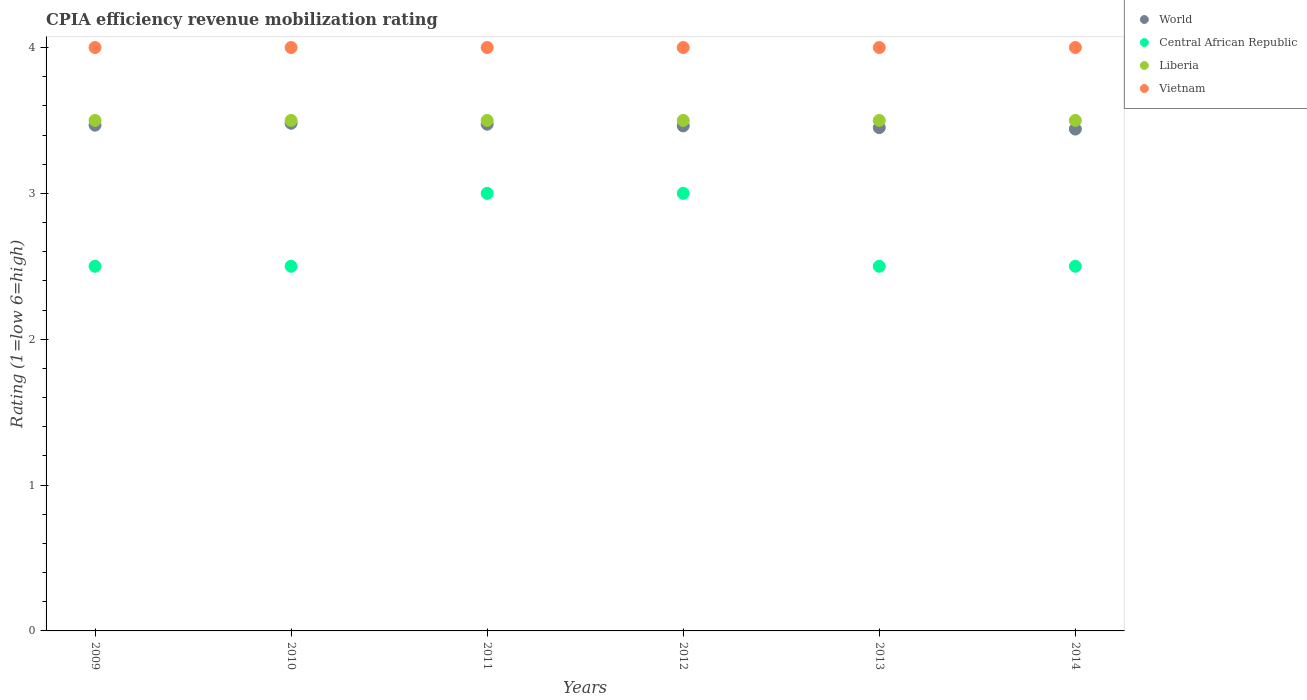How many different coloured dotlines are there?
Ensure brevity in your answer.  4. Across all years, what is the maximum CPIA rating in Vietnam?
Give a very brief answer. 4. Across all years, what is the minimum CPIA rating in Liberia?
Keep it short and to the point. 3.5. What is the difference between the CPIA rating in Vietnam in 2011 and the CPIA rating in World in 2014?
Keep it short and to the point. 0.56. What is the average CPIA rating in World per year?
Offer a terse response. 3.46. In the year 2012, what is the difference between the CPIA rating in Liberia and CPIA rating in World?
Provide a succinct answer. 0.04. In how many years, is the CPIA rating in Liberia greater than 3.4?
Make the answer very short. 6. What is the ratio of the CPIA rating in Liberia in 2009 to that in 2014?
Ensure brevity in your answer.  1. Is the difference between the CPIA rating in Liberia in 2009 and 2013 greater than the difference between the CPIA rating in World in 2009 and 2013?
Your response must be concise. No. What is the difference between the highest and the second highest CPIA rating in Liberia?
Ensure brevity in your answer.  0. Is it the case that in every year, the sum of the CPIA rating in Liberia and CPIA rating in World  is greater than the CPIA rating in Central African Republic?
Provide a short and direct response. Yes. Does the CPIA rating in World monotonically increase over the years?
Offer a terse response. No. How many dotlines are there?
Your answer should be very brief. 4. Are the values on the major ticks of Y-axis written in scientific E-notation?
Make the answer very short. No. Where does the legend appear in the graph?
Keep it short and to the point. Top right. What is the title of the graph?
Offer a terse response. CPIA efficiency revenue mobilization rating. Does "Hungary" appear as one of the legend labels in the graph?
Provide a short and direct response. No. What is the label or title of the X-axis?
Provide a short and direct response. Years. What is the Rating (1=low 6=high) of World in 2009?
Offer a very short reply. 3.47. What is the Rating (1=low 6=high) in Vietnam in 2009?
Offer a very short reply. 4. What is the Rating (1=low 6=high) of World in 2010?
Provide a short and direct response. 3.48. What is the Rating (1=low 6=high) in Liberia in 2010?
Give a very brief answer. 3.5. What is the Rating (1=low 6=high) of World in 2011?
Your answer should be compact. 3.47. What is the Rating (1=low 6=high) of Central African Republic in 2011?
Ensure brevity in your answer.  3. What is the Rating (1=low 6=high) of Vietnam in 2011?
Your answer should be compact. 4. What is the Rating (1=low 6=high) in World in 2012?
Your response must be concise. 3.46. What is the Rating (1=low 6=high) in Liberia in 2012?
Ensure brevity in your answer.  3.5. What is the Rating (1=low 6=high) in Vietnam in 2012?
Your answer should be compact. 4. What is the Rating (1=low 6=high) of World in 2013?
Your response must be concise. 3.45. What is the Rating (1=low 6=high) of Central African Republic in 2013?
Provide a short and direct response. 2.5. What is the Rating (1=low 6=high) in World in 2014?
Provide a succinct answer. 3.44. Across all years, what is the maximum Rating (1=low 6=high) in World?
Your answer should be very brief. 3.48. Across all years, what is the maximum Rating (1=low 6=high) of Central African Republic?
Provide a succinct answer. 3. Across all years, what is the minimum Rating (1=low 6=high) in World?
Offer a very short reply. 3.44. What is the total Rating (1=low 6=high) in World in the graph?
Keep it short and to the point. 20.78. What is the total Rating (1=low 6=high) of Central African Republic in the graph?
Ensure brevity in your answer.  16. What is the total Rating (1=low 6=high) of Liberia in the graph?
Give a very brief answer. 21. What is the total Rating (1=low 6=high) of Vietnam in the graph?
Your response must be concise. 24. What is the difference between the Rating (1=low 6=high) of World in 2009 and that in 2010?
Give a very brief answer. -0.01. What is the difference between the Rating (1=low 6=high) of Vietnam in 2009 and that in 2010?
Offer a terse response. 0. What is the difference between the Rating (1=low 6=high) of World in 2009 and that in 2011?
Give a very brief answer. -0.01. What is the difference between the Rating (1=low 6=high) of Liberia in 2009 and that in 2011?
Offer a terse response. 0. What is the difference between the Rating (1=low 6=high) in World in 2009 and that in 2012?
Offer a terse response. 0.01. What is the difference between the Rating (1=low 6=high) of World in 2009 and that in 2013?
Give a very brief answer. 0.02. What is the difference between the Rating (1=low 6=high) of Central African Republic in 2009 and that in 2013?
Your response must be concise. 0. What is the difference between the Rating (1=low 6=high) of Liberia in 2009 and that in 2013?
Give a very brief answer. 0. What is the difference between the Rating (1=low 6=high) in Vietnam in 2009 and that in 2013?
Your answer should be very brief. 0. What is the difference between the Rating (1=low 6=high) of World in 2009 and that in 2014?
Give a very brief answer. 0.03. What is the difference between the Rating (1=low 6=high) in Vietnam in 2009 and that in 2014?
Provide a succinct answer. 0. What is the difference between the Rating (1=low 6=high) of World in 2010 and that in 2011?
Provide a short and direct response. 0.01. What is the difference between the Rating (1=low 6=high) in Liberia in 2010 and that in 2011?
Offer a terse response. 0. What is the difference between the Rating (1=low 6=high) in Vietnam in 2010 and that in 2011?
Your answer should be very brief. 0. What is the difference between the Rating (1=low 6=high) of World in 2010 and that in 2012?
Offer a very short reply. 0.02. What is the difference between the Rating (1=low 6=high) of Liberia in 2010 and that in 2012?
Your response must be concise. 0. What is the difference between the Rating (1=low 6=high) in Vietnam in 2010 and that in 2012?
Keep it short and to the point. 0. What is the difference between the Rating (1=low 6=high) of World in 2010 and that in 2013?
Your answer should be compact. 0.03. What is the difference between the Rating (1=low 6=high) in Central African Republic in 2010 and that in 2013?
Ensure brevity in your answer.  0. What is the difference between the Rating (1=low 6=high) in Liberia in 2010 and that in 2013?
Your answer should be very brief. 0. What is the difference between the Rating (1=low 6=high) of Vietnam in 2010 and that in 2013?
Keep it short and to the point. 0. What is the difference between the Rating (1=low 6=high) in World in 2010 and that in 2014?
Provide a succinct answer. 0.04. What is the difference between the Rating (1=low 6=high) of Vietnam in 2010 and that in 2014?
Provide a short and direct response. 0. What is the difference between the Rating (1=low 6=high) in World in 2011 and that in 2012?
Provide a succinct answer. 0.01. What is the difference between the Rating (1=low 6=high) of Central African Republic in 2011 and that in 2012?
Offer a very short reply. 0. What is the difference between the Rating (1=low 6=high) in Liberia in 2011 and that in 2012?
Your response must be concise. 0. What is the difference between the Rating (1=low 6=high) of Vietnam in 2011 and that in 2012?
Your response must be concise. 0. What is the difference between the Rating (1=low 6=high) in World in 2011 and that in 2013?
Your answer should be compact. 0.02. What is the difference between the Rating (1=low 6=high) in World in 2011 and that in 2014?
Provide a succinct answer. 0.03. What is the difference between the Rating (1=low 6=high) of Liberia in 2011 and that in 2014?
Your response must be concise. 0. What is the difference between the Rating (1=low 6=high) in World in 2012 and that in 2013?
Offer a terse response. 0.01. What is the difference between the Rating (1=low 6=high) of Central African Republic in 2012 and that in 2013?
Provide a succinct answer. 0.5. What is the difference between the Rating (1=low 6=high) in Vietnam in 2012 and that in 2013?
Ensure brevity in your answer.  0. What is the difference between the Rating (1=low 6=high) in World in 2012 and that in 2014?
Offer a terse response. 0.02. What is the difference between the Rating (1=low 6=high) of World in 2013 and that in 2014?
Offer a terse response. 0.01. What is the difference between the Rating (1=low 6=high) of Central African Republic in 2013 and that in 2014?
Make the answer very short. 0. What is the difference between the Rating (1=low 6=high) of Vietnam in 2013 and that in 2014?
Your answer should be very brief. 0. What is the difference between the Rating (1=low 6=high) in World in 2009 and the Rating (1=low 6=high) in Central African Republic in 2010?
Offer a terse response. 0.97. What is the difference between the Rating (1=low 6=high) in World in 2009 and the Rating (1=low 6=high) in Liberia in 2010?
Make the answer very short. -0.03. What is the difference between the Rating (1=low 6=high) in World in 2009 and the Rating (1=low 6=high) in Vietnam in 2010?
Your answer should be compact. -0.53. What is the difference between the Rating (1=low 6=high) in Liberia in 2009 and the Rating (1=low 6=high) in Vietnam in 2010?
Your response must be concise. -0.5. What is the difference between the Rating (1=low 6=high) in World in 2009 and the Rating (1=low 6=high) in Central African Republic in 2011?
Give a very brief answer. 0.47. What is the difference between the Rating (1=low 6=high) in World in 2009 and the Rating (1=low 6=high) in Liberia in 2011?
Keep it short and to the point. -0.03. What is the difference between the Rating (1=low 6=high) in World in 2009 and the Rating (1=low 6=high) in Vietnam in 2011?
Provide a short and direct response. -0.53. What is the difference between the Rating (1=low 6=high) in Central African Republic in 2009 and the Rating (1=low 6=high) in Vietnam in 2011?
Your answer should be compact. -1.5. What is the difference between the Rating (1=low 6=high) of World in 2009 and the Rating (1=low 6=high) of Central African Republic in 2012?
Provide a short and direct response. 0.47. What is the difference between the Rating (1=low 6=high) of World in 2009 and the Rating (1=low 6=high) of Liberia in 2012?
Offer a very short reply. -0.03. What is the difference between the Rating (1=low 6=high) of World in 2009 and the Rating (1=low 6=high) of Vietnam in 2012?
Make the answer very short. -0.53. What is the difference between the Rating (1=low 6=high) in Central African Republic in 2009 and the Rating (1=low 6=high) in Liberia in 2012?
Provide a succinct answer. -1. What is the difference between the Rating (1=low 6=high) in Liberia in 2009 and the Rating (1=low 6=high) in Vietnam in 2012?
Offer a terse response. -0.5. What is the difference between the Rating (1=low 6=high) in World in 2009 and the Rating (1=low 6=high) in Central African Republic in 2013?
Make the answer very short. 0.97. What is the difference between the Rating (1=low 6=high) in World in 2009 and the Rating (1=low 6=high) in Liberia in 2013?
Your answer should be very brief. -0.03. What is the difference between the Rating (1=low 6=high) in World in 2009 and the Rating (1=low 6=high) in Vietnam in 2013?
Keep it short and to the point. -0.53. What is the difference between the Rating (1=low 6=high) of Central African Republic in 2009 and the Rating (1=low 6=high) of Liberia in 2013?
Keep it short and to the point. -1. What is the difference between the Rating (1=low 6=high) in World in 2009 and the Rating (1=low 6=high) in Central African Republic in 2014?
Make the answer very short. 0.97. What is the difference between the Rating (1=low 6=high) in World in 2009 and the Rating (1=low 6=high) in Liberia in 2014?
Offer a terse response. -0.03. What is the difference between the Rating (1=low 6=high) in World in 2009 and the Rating (1=low 6=high) in Vietnam in 2014?
Provide a succinct answer. -0.53. What is the difference between the Rating (1=low 6=high) of Central African Republic in 2009 and the Rating (1=low 6=high) of Liberia in 2014?
Ensure brevity in your answer.  -1. What is the difference between the Rating (1=low 6=high) in Central African Republic in 2009 and the Rating (1=low 6=high) in Vietnam in 2014?
Give a very brief answer. -1.5. What is the difference between the Rating (1=low 6=high) in Liberia in 2009 and the Rating (1=low 6=high) in Vietnam in 2014?
Provide a short and direct response. -0.5. What is the difference between the Rating (1=low 6=high) in World in 2010 and the Rating (1=low 6=high) in Central African Republic in 2011?
Offer a very short reply. 0.48. What is the difference between the Rating (1=low 6=high) of World in 2010 and the Rating (1=low 6=high) of Liberia in 2011?
Keep it short and to the point. -0.02. What is the difference between the Rating (1=low 6=high) in World in 2010 and the Rating (1=low 6=high) in Vietnam in 2011?
Offer a very short reply. -0.52. What is the difference between the Rating (1=low 6=high) of Central African Republic in 2010 and the Rating (1=low 6=high) of Liberia in 2011?
Give a very brief answer. -1. What is the difference between the Rating (1=low 6=high) in Liberia in 2010 and the Rating (1=low 6=high) in Vietnam in 2011?
Make the answer very short. -0.5. What is the difference between the Rating (1=low 6=high) of World in 2010 and the Rating (1=low 6=high) of Central African Republic in 2012?
Your response must be concise. 0.48. What is the difference between the Rating (1=low 6=high) in World in 2010 and the Rating (1=low 6=high) in Liberia in 2012?
Ensure brevity in your answer.  -0.02. What is the difference between the Rating (1=low 6=high) in World in 2010 and the Rating (1=low 6=high) in Vietnam in 2012?
Make the answer very short. -0.52. What is the difference between the Rating (1=low 6=high) of Central African Republic in 2010 and the Rating (1=low 6=high) of Vietnam in 2012?
Make the answer very short. -1.5. What is the difference between the Rating (1=low 6=high) in Liberia in 2010 and the Rating (1=low 6=high) in Vietnam in 2012?
Make the answer very short. -0.5. What is the difference between the Rating (1=low 6=high) in World in 2010 and the Rating (1=low 6=high) in Central African Republic in 2013?
Ensure brevity in your answer.  0.98. What is the difference between the Rating (1=low 6=high) of World in 2010 and the Rating (1=low 6=high) of Liberia in 2013?
Your response must be concise. -0.02. What is the difference between the Rating (1=low 6=high) in World in 2010 and the Rating (1=low 6=high) in Vietnam in 2013?
Ensure brevity in your answer.  -0.52. What is the difference between the Rating (1=low 6=high) of Central African Republic in 2010 and the Rating (1=low 6=high) of Liberia in 2013?
Offer a terse response. -1. What is the difference between the Rating (1=low 6=high) of Central African Republic in 2010 and the Rating (1=low 6=high) of Vietnam in 2013?
Keep it short and to the point. -1.5. What is the difference between the Rating (1=low 6=high) in World in 2010 and the Rating (1=low 6=high) in Central African Republic in 2014?
Provide a succinct answer. 0.98. What is the difference between the Rating (1=low 6=high) in World in 2010 and the Rating (1=low 6=high) in Liberia in 2014?
Your answer should be compact. -0.02. What is the difference between the Rating (1=low 6=high) in World in 2010 and the Rating (1=low 6=high) in Vietnam in 2014?
Offer a very short reply. -0.52. What is the difference between the Rating (1=low 6=high) of Central African Republic in 2010 and the Rating (1=low 6=high) of Liberia in 2014?
Ensure brevity in your answer.  -1. What is the difference between the Rating (1=low 6=high) in Liberia in 2010 and the Rating (1=low 6=high) in Vietnam in 2014?
Make the answer very short. -0.5. What is the difference between the Rating (1=low 6=high) in World in 2011 and the Rating (1=low 6=high) in Central African Republic in 2012?
Offer a very short reply. 0.47. What is the difference between the Rating (1=low 6=high) in World in 2011 and the Rating (1=low 6=high) in Liberia in 2012?
Ensure brevity in your answer.  -0.03. What is the difference between the Rating (1=low 6=high) in World in 2011 and the Rating (1=low 6=high) in Vietnam in 2012?
Your response must be concise. -0.53. What is the difference between the Rating (1=low 6=high) of Central African Republic in 2011 and the Rating (1=low 6=high) of Liberia in 2012?
Your answer should be compact. -0.5. What is the difference between the Rating (1=low 6=high) in World in 2011 and the Rating (1=low 6=high) in Central African Republic in 2013?
Your answer should be compact. 0.97. What is the difference between the Rating (1=low 6=high) in World in 2011 and the Rating (1=low 6=high) in Liberia in 2013?
Make the answer very short. -0.03. What is the difference between the Rating (1=low 6=high) of World in 2011 and the Rating (1=low 6=high) of Vietnam in 2013?
Your answer should be very brief. -0.53. What is the difference between the Rating (1=low 6=high) in World in 2011 and the Rating (1=low 6=high) in Central African Republic in 2014?
Your response must be concise. 0.97. What is the difference between the Rating (1=low 6=high) of World in 2011 and the Rating (1=low 6=high) of Liberia in 2014?
Ensure brevity in your answer.  -0.03. What is the difference between the Rating (1=low 6=high) in World in 2011 and the Rating (1=low 6=high) in Vietnam in 2014?
Your answer should be compact. -0.53. What is the difference between the Rating (1=low 6=high) of Central African Republic in 2011 and the Rating (1=low 6=high) of Liberia in 2014?
Keep it short and to the point. -0.5. What is the difference between the Rating (1=low 6=high) of Central African Republic in 2011 and the Rating (1=low 6=high) of Vietnam in 2014?
Make the answer very short. -1. What is the difference between the Rating (1=low 6=high) of Liberia in 2011 and the Rating (1=low 6=high) of Vietnam in 2014?
Your response must be concise. -0.5. What is the difference between the Rating (1=low 6=high) of World in 2012 and the Rating (1=low 6=high) of Central African Republic in 2013?
Provide a succinct answer. 0.96. What is the difference between the Rating (1=low 6=high) in World in 2012 and the Rating (1=low 6=high) in Liberia in 2013?
Make the answer very short. -0.04. What is the difference between the Rating (1=low 6=high) in World in 2012 and the Rating (1=low 6=high) in Vietnam in 2013?
Keep it short and to the point. -0.54. What is the difference between the Rating (1=low 6=high) in Central African Republic in 2012 and the Rating (1=low 6=high) in Liberia in 2013?
Your answer should be compact. -0.5. What is the difference between the Rating (1=low 6=high) in Central African Republic in 2012 and the Rating (1=low 6=high) in Vietnam in 2013?
Your answer should be compact. -1. What is the difference between the Rating (1=low 6=high) of World in 2012 and the Rating (1=low 6=high) of Central African Republic in 2014?
Ensure brevity in your answer.  0.96. What is the difference between the Rating (1=low 6=high) of World in 2012 and the Rating (1=low 6=high) of Liberia in 2014?
Offer a terse response. -0.04. What is the difference between the Rating (1=low 6=high) in World in 2012 and the Rating (1=low 6=high) in Vietnam in 2014?
Your answer should be compact. -0.54. What is the difference between the Rating (1=low 6=high) of Central African Republic in 2012 and the Rating (1=low 6=high) of Vietnam in 2014?
Your answer should be very brief. -1. What is the difference between the Rating (1=low 6=high) of Liberia in 2012 and the Rating (1=low 6=high) of Vietnam in 2014?
Offer a terse response. -0.5. What is the difference between the Rating (1=low 6=high) in World in 2013 and the Rating (1=low 6=high) in Central African Republic in 2014?
Make the answer very short. 0.95. What is the difference between the Rating (1=low 6=high) of World in 2013 and the Rating (1=low 6=high) of Liberia in 2014?
Provide a succinct answer. -0.05. What is the difference between the Rating (1=low 6=high) in World in 2013 and the Rating (1=low 6=high) in Vietnam in 2014?
Make the answer very short. -0.55. What is the difference between the Rating (1=low 6=high) of Liberia in 2013 and the Rating (1=low 6=high) of Vietnam in 2014?
Provide a succinct answer. -0.5. What is the average Rating (1=low 6=high) of World per year?
Provide a short and direct response. 3.46. What is the average Rating (1=low 6=high) of Central African Republic per year?
Offer a very short reply. 2.67. What is the average Rating (1=low 6=high) in Vietnam per year?
Ensure brevity in your answer.  4. In the year 2009, what is the difference between the Rating (1=low 6=high) in World and Rating (1=low 6=high) in Central African Republic?
Make the answer very short. 0.97. In the year 2009, what is the difference between the Rating (1=low 6=high) in World and Rating (1=low 6=high) in Liberia?
Offer a very short reply. -0.03. In the year 2009, what is the difference between the Rating (1=low 6=high) in World and Rating (1=low 6=high) in Vietnam?
Your answer should be very brief. -0.53. In the year 2009, what is the difference between the Rating (1=low 6=high) in Central African Republic and Rating (1=low 6=high) in Liberia?
Ensure brevity in your answer.  -1. In the year 2010, what is the difference between the Rating (1=low 6=high) in World and Rating (1=low 6=high) in Central African Republic?
Make the answer very short. 0.98. In the year 2010, what is the difference between the Rating (1=low 6=high) of World and Rating (1=low 6=high) of Liberia?
Your response must be concise. -0.02. In the year 2010, what is the difference between the Rating (1=low 6=high) of World and Rating (1=low 6=high) of Vietnam?
Make the answer very short. -0.52. In the year 2010, what is the difference between the Rating (1=low 6=high) in Central African Republic and Rating (1=low 6=high) in Liberia?
Keep it short and to the point. -1. In the year 2010, what is the difference between the Rating (1=low 6=high) of Central African Republic and Rating (1=low 6=high) of Vietnam?
Keep it short and to the point. -1.5. In the year 2010, what is the difference between the Rating (1=low 6=high) of Liberia and Rating (1=low 6=high) of Vietnam?
Keep it short and to the point. -0.5. In the year 2011, what is the difference between the Rating (1=low 6=high) of World and Rating (1=low 6=high) of Central African Republic?
Offer a very short reply. 0.47. In the year 2011, what is the difference between the Rating (1=low 6=high) of World and Rating (1=low 6=high) of Liberia?
Offer a very short reply. -0.03. In the year 2011, what is the difference between the Rating (1=low 6=high) of World and Rating (1=low 6=high) of Vietnam?
Your answer should be very brief. -0.53. In the year 2012, what is the difference between the Rating (1=low 6=high) in World and Rating (1=low 6=high) in Central African Republic?
Provide a succinct answer. 0.46. In the year 2012, what is the difference between the Rating (1=low 6=high) of World and Rating (1=low 6=high) of Liberia?
Provide a succinct answer. -0.04. In the year 2012, what is the difference between the Rating (1=low 6=high) in World and Rating (1=low 6=high) in Vietnam?
Your answer should be compact. -0.54. In the year 2012, what is the difference between the Rating (1=low 6=high) of Central African Republic and Rating (1=low 6=high) of Liberia?
Your answer should be very brief. -0.5. In the year 2013, what is the difference between the Rating (1=low 6=high) in World and Rating (1=low 6=high) in Central African Republic?
Keep it short and to the point. 0.95. In the year 2013, what is the difference between the Rating (1=low 6=high) in World and Rating (1=low 6=high) in Liberia?
Your answer should be very brief. -0.05. In the year 2013, what is the difference between the Rating (1=low 6=high) in World and Rating (1=low 6=high) in Vietnam?
Your answer should be compact. -0.55. In the year 2013, what is the difference between the Rating (1=low 6=high) of Central African Republic and Rating (1=low 6=high) of Liberia?
Give a very brief answer. -1. In the year 2013, what is the difference between the Rating (1=low 6=high) of Central African Republic and Rating (1=low 6=high) of Vietnam?
Provide a short and direct response. -1.5. In the year 2013, what is the difference between the Rating (1=low 6=high) in Liberia and Rating (1=low 6=high) in Vietnam?
Offer a very short reply. -0.5. In the year 2014, what is the difference between the Rating (1=low 6=high) of World and Rating (1=low 6=high) of Central African Republic?
Offer a terse response. 0.94. In the year 2014, what is the difference between the Rating (1=low 6=high) of World and Rating (1=low 6=high) of Liberia?
Your response must be concise. -0.06. In the year 2014, what is the difference between the Rating (1=low 6=high) in World and Rating (1=low 6=high) in Vietnam?
Make the answer very short. -0.56. In the year 2014, what is the difference between the Rating (1=low 6=high) of Central African Republic and Rating (1=low 6=high) of Vietnam?
Offer a terse response. -1.5. What is the ratio of the Rating (1=low 6=high) in World in 2009 to that in 2010?
Offer a terse response. 1. What is the ratio of the Rating (1=low 6=high) in Central African Republic in 2009 to that in 2011?
Your answer should be compact. 0.83. What is the ratio of the Rating (1=low 6=high) in Liberia in 2009 to that in 2012?
Make the answer very short. 1. What is the ratio of the Rating (1=low 6=high) of Vietnam in 2009 to that in 2013?
Offer a very short reply. 1. What is the ratio of the Rating (1=low 6=high) in Liberia in 2010 to that in 2011?
Your answer should be very brief. 1. What is the ratio of the Rating (1=low 6=high) in Vietnam in 2010 to that in 2011?
Give a very brief answer. 1. What is the ratio of the Rating (1=low 6=high) of Central African Republic in 2010 to that in 2012?
Make the answer very short. 0.83. What is the ratio of the Rating (1=low 6=high) of Vietnam in 2010 to that in 2012?
Your answer should be compact. 1. What is the ratio of the Rating (1=low 6=high) of World in 2010 to that in 2013?
Your answer should be very brief. 1.01. What is the ratio of the Rating (1=low 6=high) in Liberia in 2010 to that in 2013?
Keep it short and to the point. 1. What is the ratio of the Rating (1=low 6=high) in World in 2010 to that in 2014?
Provide a short and direct response. 1.01. What is the ratio of the Rating (1=low 6=high) of Central African Republic in 2010 to that in 2014?
Keep it short and to the point. 1. What is the ratio of the Rating (1=low 6=high) of Vietnam in 2010 to that in 2014?
Offer a terse response. 1. What is the ratio of the Rating (1=low 6=high) in Central African Republic in 2011 to that in 2012?
Give a very brief answer. 1. What is the ratio of the Rating (1=low 6=high) of Central African Republic in 2011 to that in 2013?
Give a very brief answer. 1.2. What is the ratio of the Rating (1=low 6=high) of Liberia in 2011 to that in 2013?
Make the answer very short. 1. What is the ratio of the Rating (1=low 6=high) in World in 2011 to that in 2014?
Provide a succinct answer. 1.01. What is the ratio of the Rating (1=low 6=high) of Central African Republic in 2011 to that in 2014?
Make the answer very short. 1.2. What is the ratio of the Rating (1=low 6=high) in Liberia in 2011 to that in 2014?
Your response must be concise. 1. What is the ratio of the Rating (1=low 6=high) of Vietnam in 2011 to that in 2014?
Keep it short and to the point. 1. What is the ratio of the Rating (1=low 6=high) of Central African Republic in 2012 to that in 2013?
Your response must be concise. 1.2. What is the ratio of the Rating (1=low 6=high) of Vietnam in 2012 to that in 2013?
Provide a succinct answer. 1. What is the ratio of the Rating (1=low 6=high) of World in 2012 to that in 2014?
Provide a succinct answer. 1.01. What is the ratio of the Rating (1=low 6=high) of Central African Republic in 2012 to that in 2014?
Make the answer very short. 1.2. What is the ratio of the Rating (1=low 6=high) in Vietnam in 2012 to that in 2014?
Your answer should be compact. 1. What is the ratio of the Rating (1=low 6=high) of World in 2013 to that in 2014?
Your response must be concise. 1. What is the ratio of the Rating (1=low 6=high) of Central African Republic in 2013 to that in 2014?
Ensure brevity in your answer.  1. What is the ratio of the Rating (1=low 6=high) in Liberia in 2013 to that in 2014?
Offer a terse response. 1. What is the ratio of the Rating (1=low 6=high) of Vietnam in 2013 to that in 2014?
Offer a terse response. 1. What is the difference between the highest and the second highest Rating (1=low 6=high) of World?
Ensure brevity in your answer.  0.01. What is the difference between the highest and the second highest Rating (1=low 6=high) of Liberia?
Your response must be concise. 0. What is the difference between the highest and the second highest Rating (1=low 6=high) of Vietnam?
Keep it short and to the point. 0. What is the difference between the highest and the lowest Rating (1=low 6=high) in World?
Offer a terse response. 0.04. What is the difference between the highest and the lowest Rating (1=low 6=high) in Central African Republic?
Offer a terse response. 0.5. 